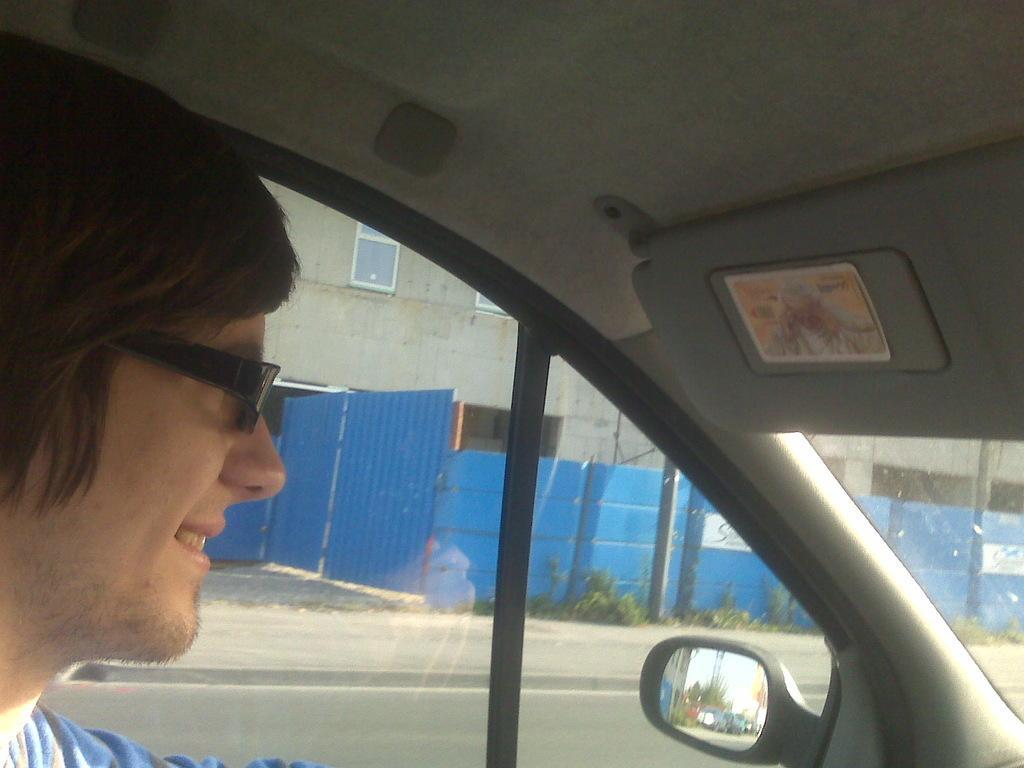Please provide a concise description of this image. In this image I can see a person wearing blue colored dress is sitting inside a vehicle and wearing black colored spectacles. Through the window of the vehicle I can see a building, few windows, few plants and the blue colored wall. In the side mirror of the vehicle I can see the reflection of few buildings, few trees, few vehicles and the sky. 